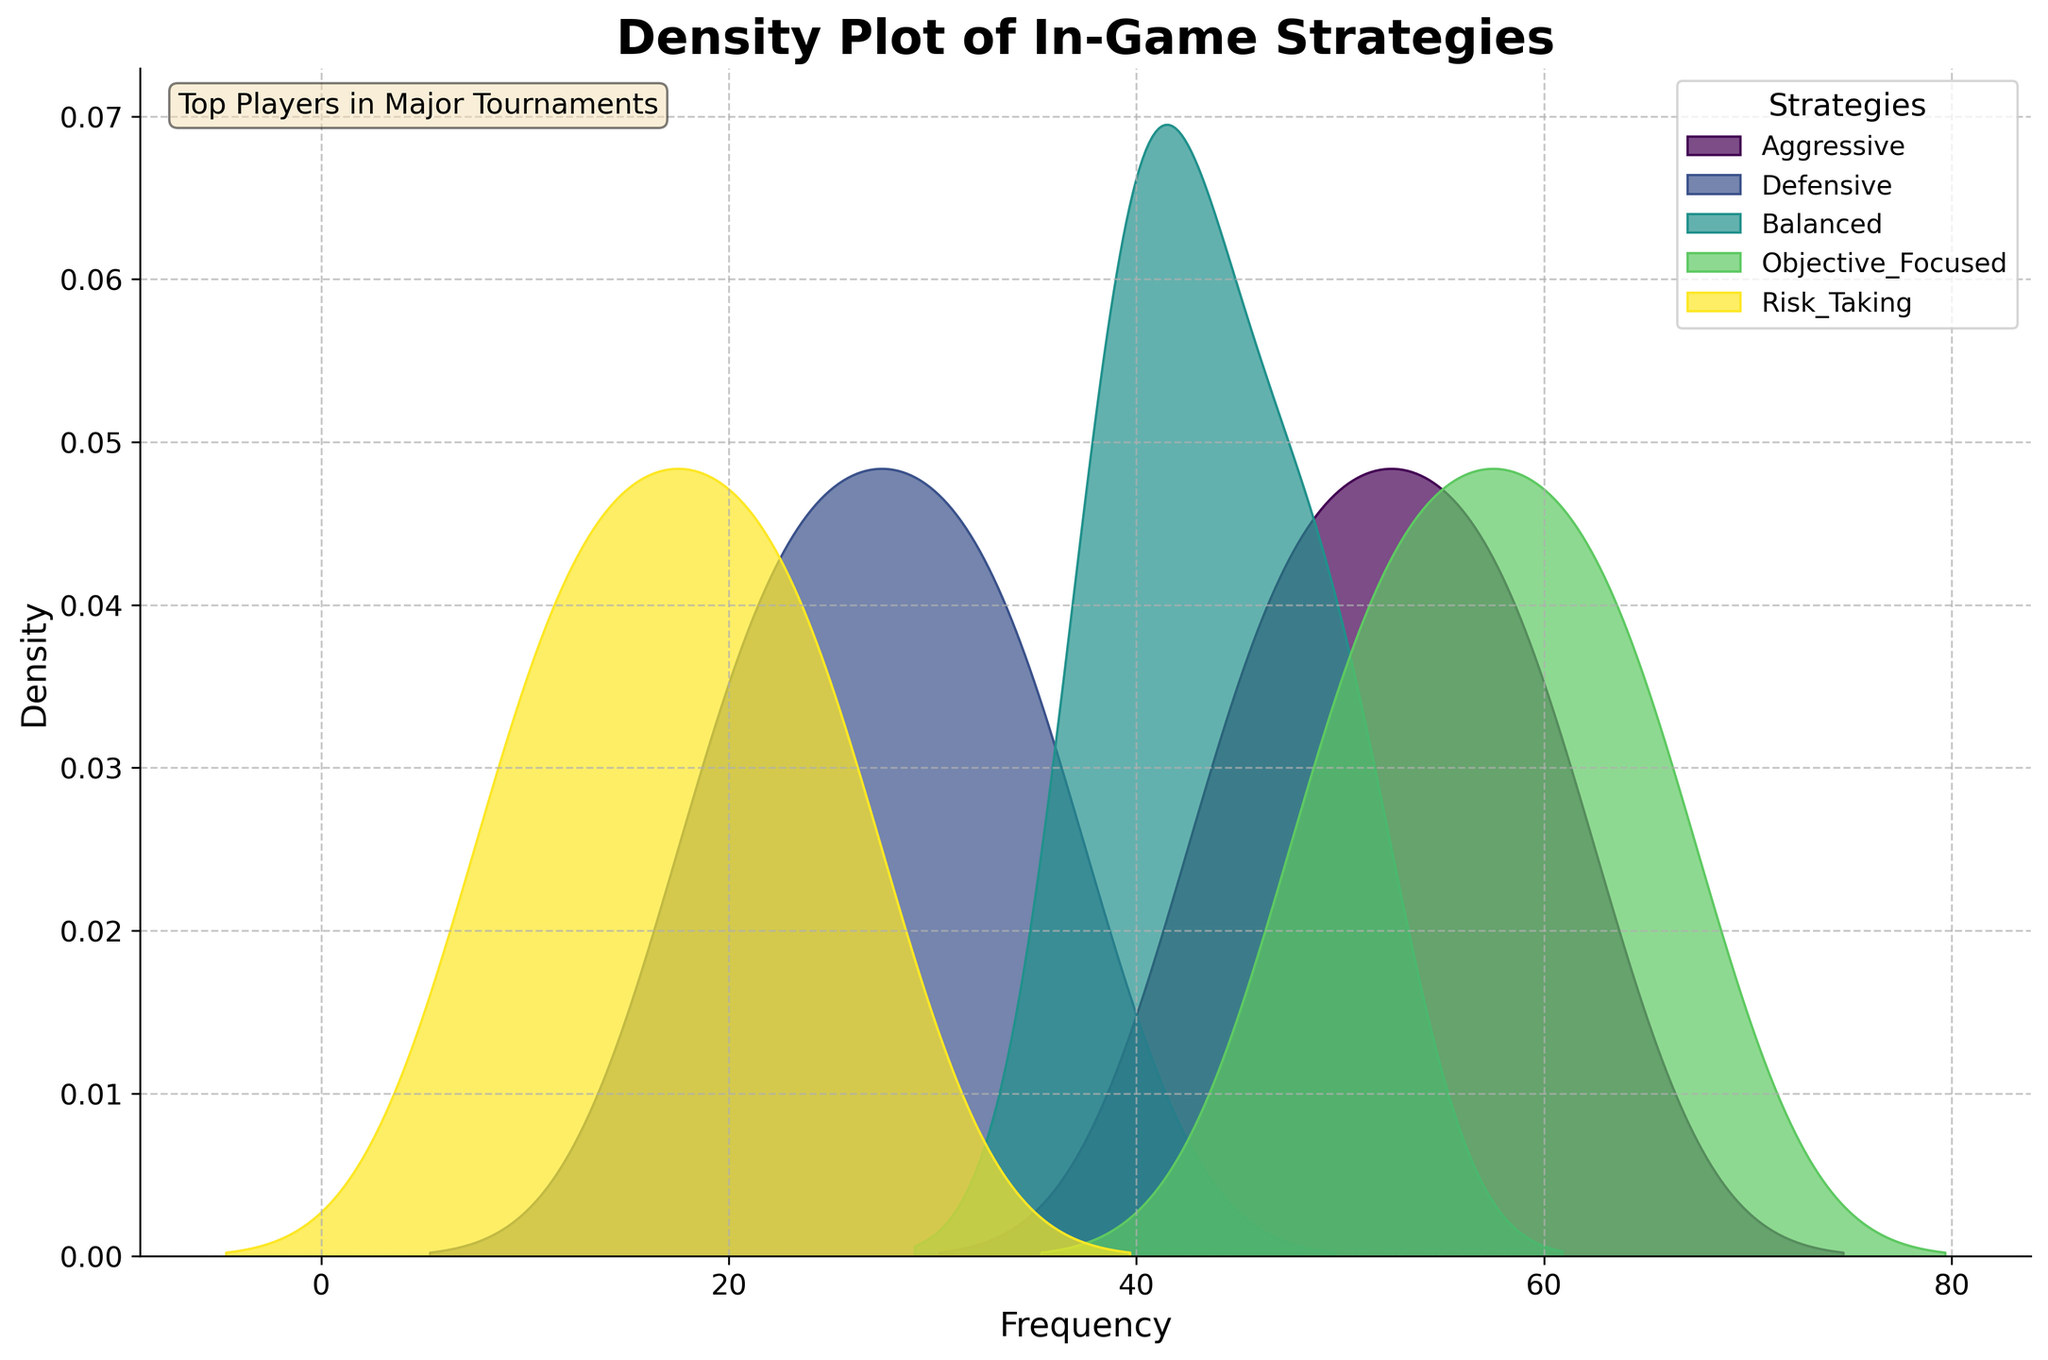What is the title of the plot? The title of the plot is usually displayed at the top, written in a large and bold font. Here, it is clearly visible at the top of the plot.
Answer: Density Plot of In-Game Strategies Which strategy has the highest peak density? By examining the density peaks in the figure, it is evident which strategy has the highest frequency value at its peak.
Answer: Objective_Focused At what frequency range does the 'Defensive' strategy show the highest density? The highest density for a strategy in a density plot is indicated by the tallest point of its curve. For the 'Defensive' strategy, this peak can be identified on the x-axis.
Answer: 20-30 Between which frequencies do the 'Risk_Taking' strategy densities fall predominantly? Observing the density plot for the 'Risk_Taking' strategy, the area under the curve will show where most of its values are concentrated along the x-axis.
Answer: 10-25 Compare the density peaks of 'Aggressive' and 'Balanced' strategies. Which one is higher? Looking at the points on the y-axis where the peaks for 'Aggressive' and 'Balanced' strategies occur, we can see which one reaches a higher value.
Answer: Aggressive What's the approximate range of frequencies where the 'Balanced' strategy has a significant density? By looking at the area where the 'Balanced' density curve is visibly wider and taller, we can infer the frequency range it covers.
Answer: 40-50 How does the density distribution of 'Objective_Focused' strategy compare to 'Risk_Taking'? We observe that 'Objective_Focused' has a wider spread and higher peak densities, indicating it is more frequently used compared to 'Risk_Taking', which has lower and narrower density peaks.
Answer: Objective_Focused is higher and wider Summarize the spread of frequencies for the 'Aggressive' strategy. Observing the width and shape of the density curve for the 'Aggressive' strategy provides insights into the range of frequencies where this strategy is employed.
Answer: 45-60 Which strategy shows a bimodal distribution, if any? A bimodal distribution is indicated by two distinct peaks in the density plot. By examining the curves, we look for any strategy that might exhibit this feature.
Answer: None 